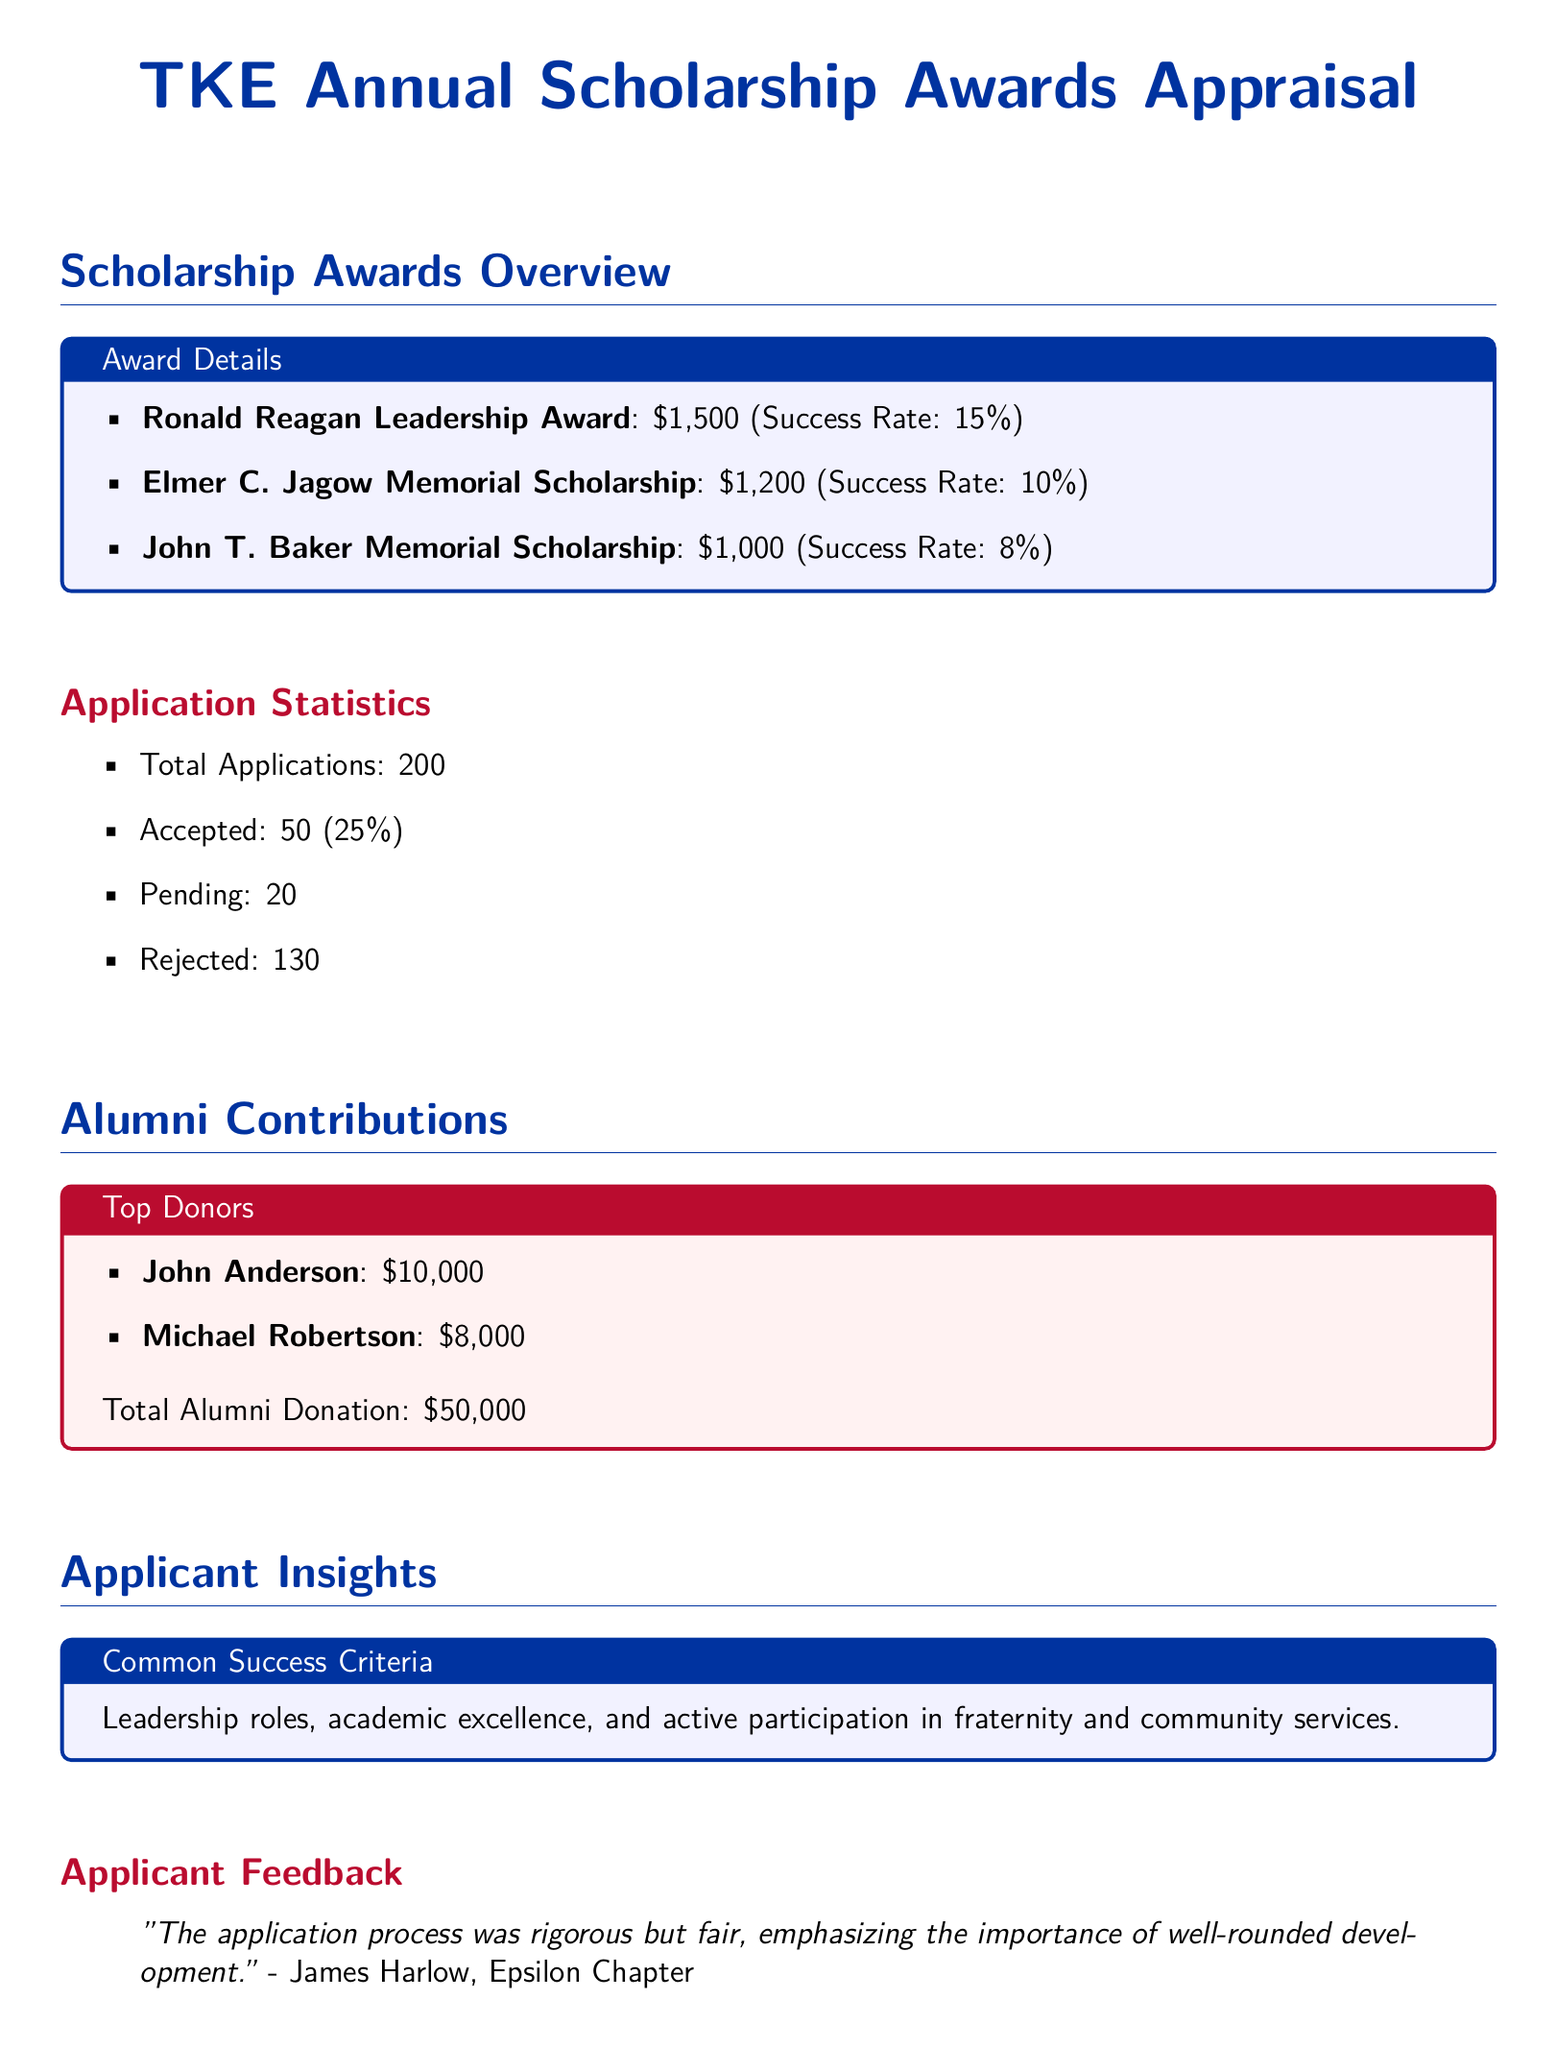What is the total number of applications? The total number of applications is listed in the document under "Application Statistics."
Answer: 200 What is the success rate of the Ronald Reagan Leadership Award? The success rate is specified next to the award title in the award details section.
Answer: 15% Who is the top donor listed in the document? The top donor is mentioned in the "Top Donors" section, indicating their contribution amount.
Answer: John Anderson How many applications were rejected? The number of rejected applications is also included in the "Application Statistics" section.
Answer: 130 What is the total amount of alumni donations? The total alumni donation is provided in the "Top Donors" section of the document.
Answer: $50,000 What criteria are commonly associated with successful applicants? Common success criteria are outlined in the "Common Success Criteria" box within the document.
Answer: Leadership roles, academic excellence, and active participation What was the feedback from a specific applicant about the application process? The quote includes the views of an applicant regarding the process's nature, found in the "Applicant Feedback" section.
Answer: “rigorous but fair” What is the title of the scholarship with the lowest success rate? The title can be found in the "Scholarship Awards Overview" section, specifically near its success rate.
Answer: John T. Baker Memorial Scholarship What percentage of applications were accepted? The acceptance percentage is calculated based on the total applications and accepted applications, mentioned in the statistics.
Answer: 25% 